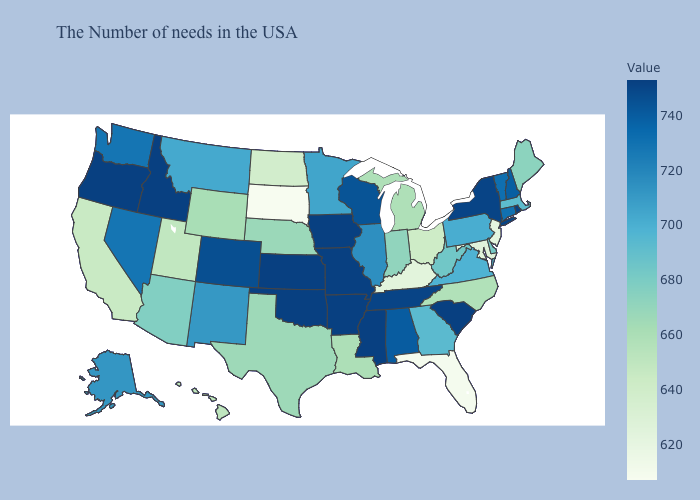Among the states that border Rhode Island , which have the highest value?
Quick response, please. Connecticut. Among the states that border Oklahoma , does Texas have the lowest value?
Be succinct. Yes. Among the states that border Pennsylvania , does West Virginia have the lowest value?
Be succinct. No. Does Kentucky have the highest value in the South?
Quick response, please. No. 